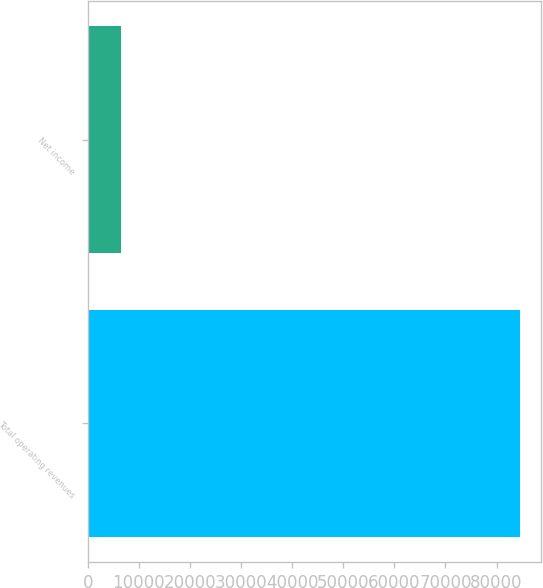Convert chart. <chart><loc_0><loc_0><loc_500><loc_500><bar_chart><fcel>Total operating revenues<fcel>Net income<nl><fcel>84514<fcel>6423<nl></chart> 